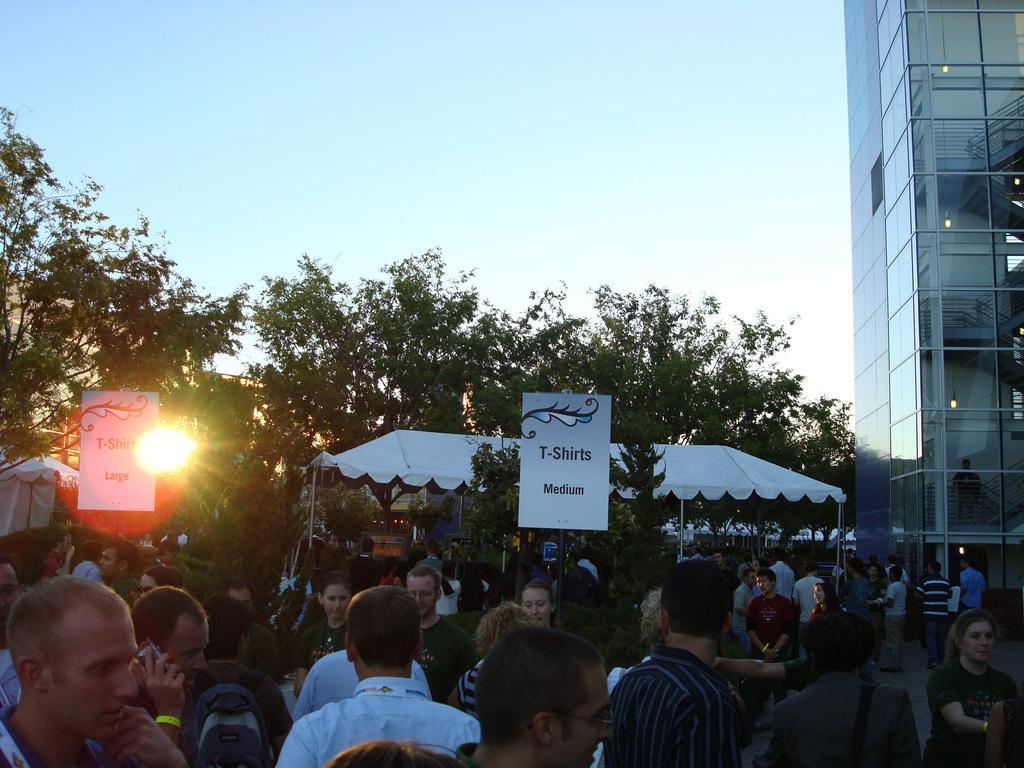Describe this image in one or two sentences. In this image we can see many people. Also there are boards with text. In the back there are trees. Also there is a shed. And we can see a light. On the right side there is a building. In the background there is sky. 